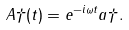Convert formula to latex. <formula><loc_0><loc_0><loc_500><loc_500>A \dag ( t ) = e ^ { - i \omega t } a \dag .</formula> 